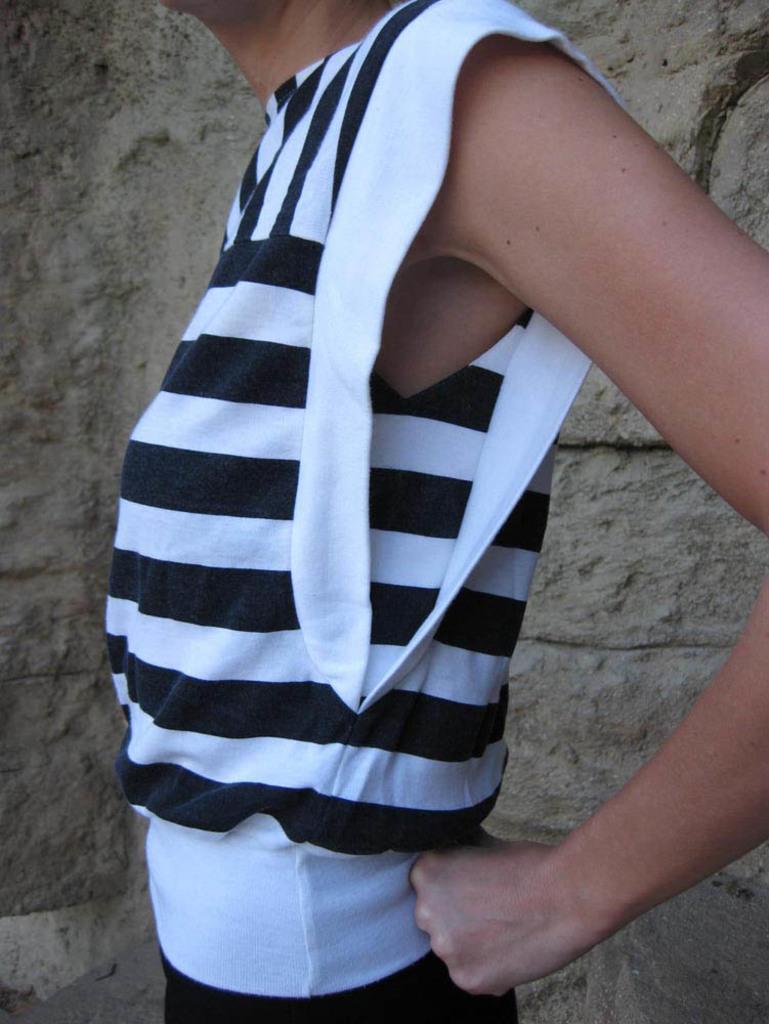In one or two sentences, can you explain what this image depicts? In this image there is a person, behind the person there is a wall. 